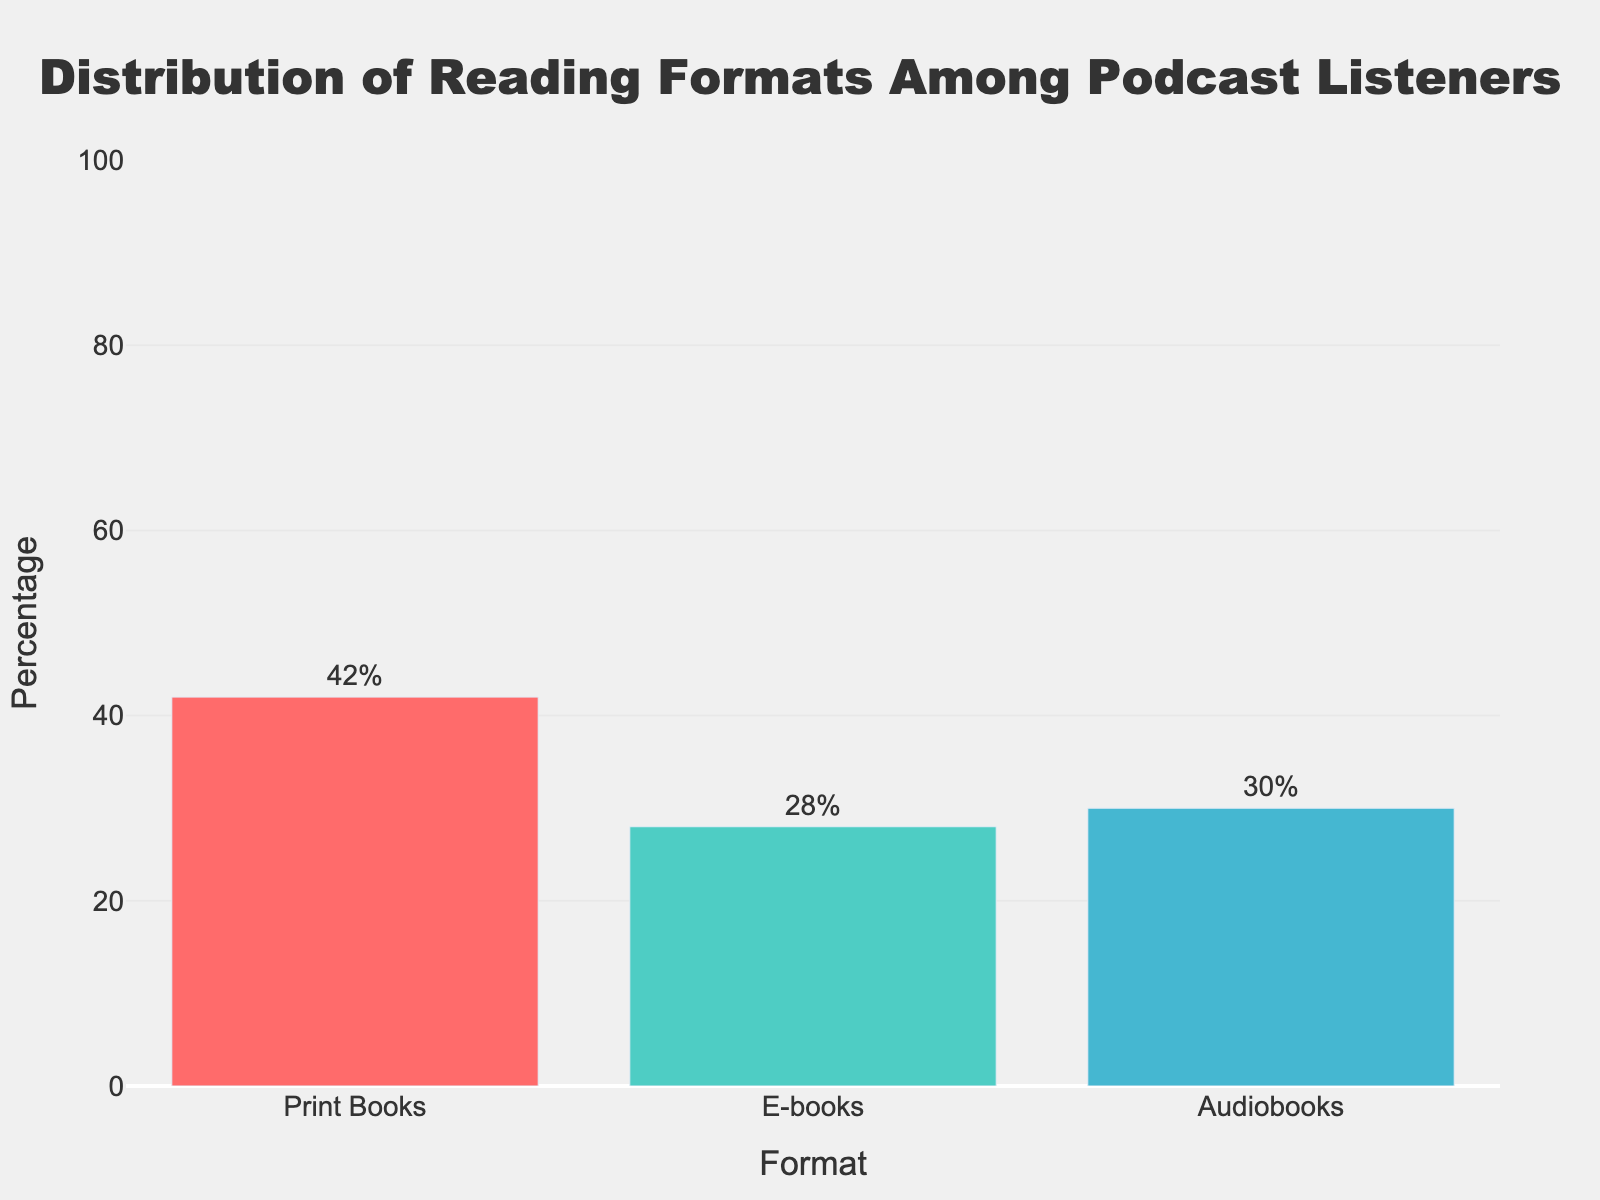What's the percentage of podcast listeners who prefer e-books? Referring to the figure, the height of the bar representing e-books displays a percentage of 28%.
Answer: 28% Which reading format is the most popular among podcast listeners? By examining the heights of the bars, the bar for Print Books is the tallest, indicating it is the most popular format.
Answer: Print Books How much more popular are print books than audiobooks among podcast listeners? The percentage for Print Books is 42%, and for Audiobooks it is 30%. Subtracting the percentage of Audiobooks from Print Books (42% - 30%) gives us the difference.
Answer: 12% What is the total percentage of podcast listeners who prefer digital formats (e-books and audiobooks)? Add the percentages of e-books (28%) and audiobooks (30%) together. The sum is 28% + 30% = 58%.
Answer: 58% Compare the popularity of audiobooks to e-books among podcast listeners. Which is more popular and by how much? Referring to the figure, the percentage for Audiobooks is 30% and for e-books is 28%. The Audiobooks percentage is slightly higher. Subtracting the percentage of e-books from Audiobooks (30% - 28%) gives us the difference.
Answer: Audiobooks by 2% What is the average percentage of the three reading formats among podcast listeners? To find the average, sum the percentages of Print Books (42%), e-books (28%), and Audiobooks (30%). Then, divide by the number of formats (3). (42% + 28% + 30%) / 3 = 100% / 3.
Answer: 33.33% If the percentage of audiobook listeners were to increase by 5%, what would the new percentage be? The current percentage for Audiobooks is 30%. An increase of 5% would be calculated as 30% + 5%.
Answer: 35% Which reading format has the smallest percentage among podcast listeners? By visually comparing the heights of all bars, the shortest bar corresponds to e-books, which indicates it has the smallest percentage.
Answer: E-books What is the combined percentage for print and e-book formats among podcast listeners? Adding the percentages of Print Books (42%) and e-books (28%) together. The sum is 42% + 28% = 70%.
Answer: 70% 